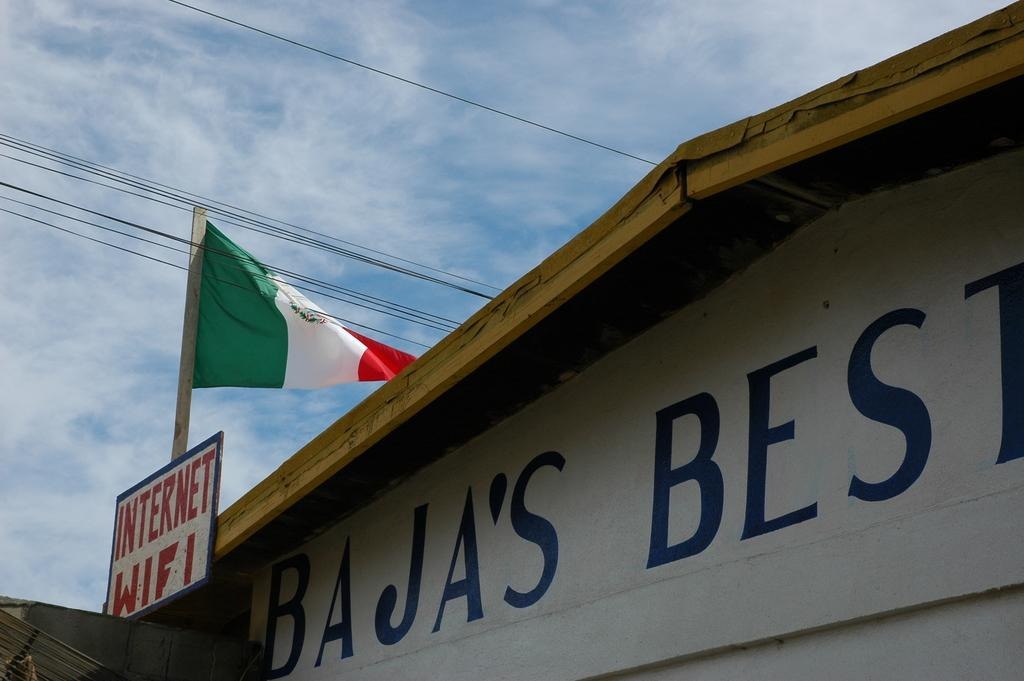What object in the image is typically used as a symbol or representation? There is a flag in the image, which is typically used as a symbol or representation. What other object can be seen in the image? There is a board in the image. What color is the sky at the top of the image? The sky is blue in color at the top of the image. What type of butter is being used on the actor's thumb in the image? There is no actor, thumb, or butter present in the image. 